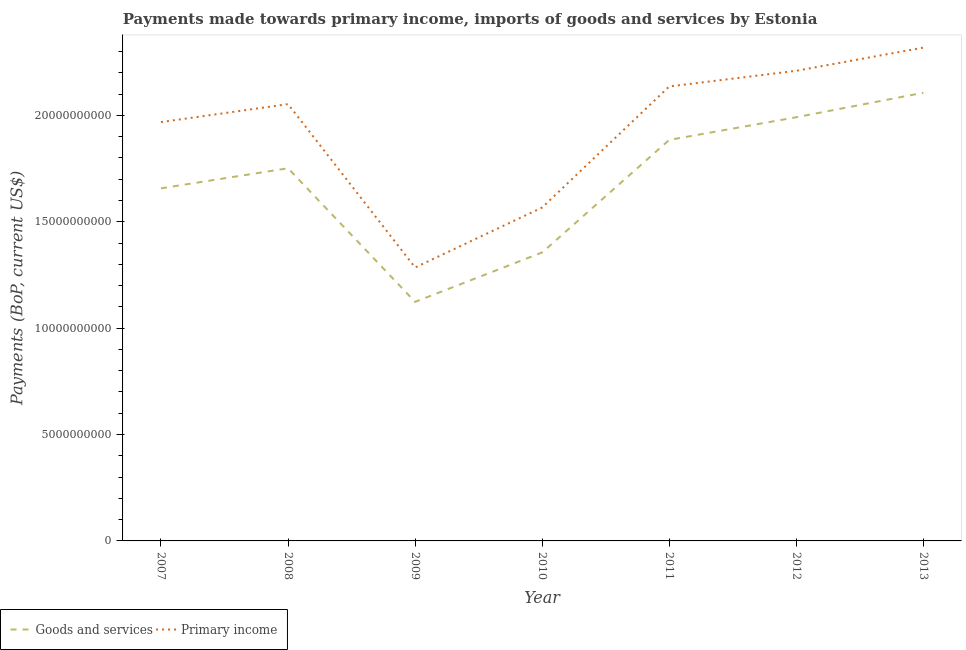How many different coloured lines are there?
Your answer should be very brief. 2. Does the line corresponding to payments made towards primary income intersect with the line corresponding to payments made towards goods and services?
Make the answer very short. No. Is the number of lines equal to the number of legend labels?
Offer a very short reply. Yes. What is the payments made towards goods and services in 2010?
Offer a terse response. 1.36e+1. Across all years, what is the maximum payments made towards primary income?
Provide a succinct answer. 2.32e+1. Across all years, what is the minimum payments made towards goods and services?
Give a very brief answer. 1.12e+1. In which year was the payments made towards primary income minimum?
Your answer should be very brief. 2009. What is the total payments made towards primary income in the graph?
Provide a succinct answer. 1.35e+11. What is the difference between the payments made towards goods and services in 2008 and that in 2010?
Your answer should be very brief. 3.96e+09. What is the difference between the payments made towards primary income in 2013 and the payments made towards goods and services in 2007?
Offer a terse response. 6.61e+09. What is the average payments made towards primary income per year?
Offer a terse response. 1.93e+1. In the year 2011, what is the difference between the payments made towards goods and services and payments made towards primary income?
Keep it short and to the point. -2.51e+09. What is the ratio of the payments made towards primary income in 2007 to that in 2008?
Your answer should be very brief. 0.96. What is the difference between the highest and the second highest payments made towards primary income?
Give a very brief answer. 1.09e+09. What is the difference between the highest and the lowest payments made towards goods and services?
Ensure brevity in your answer.  9.83e+09. Is the sum of the payments made towards primary income in 2007 and 2012 greater than the maximum payments made towards goods and services across all years?
Keep it short and to the point. Yes. Does the payments made towards primary income monotonically increase over the years?
Your answer should be compact. No. Is the payments made towards primary income strictly less than the payments made towards goods and services over the years?
Offer a very short reply. No. How many lines are there?
Your answer should be very brief. 2. Does the graph contain any zero values?
Keep it short and to the point. No. Does the graph contain grids?
Keep it short and to the point. No. Where does the legend appear in the graph?
Your answer should be very brief. Bottom left. How are the legend labels stacked?
Offer a terse response. Horizontal. What is the title of the graph?
Your answer should be very brief. Payments made towards primary income, imports of goods and services by Estonia. What is the label or title of the X-axis?
Keep it short and to the point. Year. What is the label or title of the Y-axis?
Provide a short and direct response. Payments (BoP, current US$). What is the Payments (BoP, current US$) in Goods and services in 2007?
Your response must be concise. 1.66e+1. What is the Payments (BoP, current US$) of Primary income in 2007?
Provide a short and direct response. 1.97e+1. What is the Payments (BoP, current US$) in Goods and services in 2008?
Offer a terse response. 1.75e+1. What is the Payments (BoP, current US$) of Primary income in 2008?
Offer a very short reply. 2.05e+1. What is the Payments (BoP, current US$) of Goods and services in 2009?
Make the answer very short. 1.12e+1. What is the Payments (BoP, current US$) in Primary income in 2009?
Your answer should be compact. 1.29e+1. What is the Payments (BoP, current US$) in Goods and services in 2010?
Provide a succinct answer. 1.36e+1. What is the Payments (BoP, current US$) of Primary income in 2010?
Provide a short and direct response. 1.57e+1. What is the Payments (BoP, current US$) of Goods and services in 2011?
Make the answer very short. 1.88e+1. What is the Payments (BoP, current US$) of Primary income in 2011?
Ensure brevity in your answer.  2.14e+1. What is the Payments (BoP, current US$) in Goods and services in 2012?
Offer a very short reply. 1.99e+1. What is the Payments (BoP, current US$) of Primary income in 2012?
Offer a very short reply. 2.21e+1. What is the Payments (BoP, current US$) of Goods and services in 2013?
Ensure brevity in your answer.  2.11e+1. What is the Payments (BoP, current US$) in Primary income in 2013?
Give a very brief answer. 2.32e+1. Across all years, what is the maximum Payments (BoP, current US$) of Goods and services?
Your response must be concise. 2.11e+1. Across all years, what is the maximum Payments (BoP, current US$) of Primary income?
Keep it short and to the point. 2.32e+1. Across all years, what is the minimum Payments (BoP, current US$) of Goods and services?
Offer a terse response. 1.12e+1. Across all years, what is the minimum Payments (BoP, current US$) of Primary income?
Your answer should be compact. 1.29e+1. What is the total Payments (BoP, current US$) in Goods and services in the graph?
Ensure brevity in your answer.  1.19e+11. What is the total Payments (BoP, current US$) of Primary income in the graph?
Make the answer very short. 1.35e+11. What is the difference between the Payments (BoP, current US$) of Goods and services in 2007 and that in 2008?
Provide a short and direct response. -9.43e+08. What is the difference between the Payments (BoP, current US$) in Primary income in 2007 and that in 2008?
Offer a terse response. -8.45e+08. What is the difference between the Payments (BoP, current US$) of Goods and services in 2007 and that in 2009?
Make the answer very short. 5.34e+09. What is the difference between the Payments (BoP, current US$) of Primary income in 2007 and that in 2009?
Give a very brief answer. 6.83e+09. What is the difference between the Payments (BoP, current US$) of Goods and services in 2007 and that in 2010?
Give a very brief answer. 3.01e+09. What is the difference between the Payments (BoP, current US$) in Primary income in 2007 and that in 2010?
Provide a succinct answer. 4.01e+09. What is the difference between the Payments (BoP, current US$) in Goods and services in 2007 and that in 2011?
Give a very brief answer. -2.28e+09. What is the difference between the Payments (BoP, current US$) of Primary income in 2007 and that in 2011?
Provide a short and direct response. -1.67e+09. What is the difference between the Payments (BoP, current US$) in Goods and services in 2007 and that in 2012?
Provide a succinct answer. -3.34e+09. What is the difference between the Payments (BoP, current US$) in Primary income in 2007 and that in 2012?
Your response must be concise. -2.41e+09. What is the difference between the Payments (BoP, current US$) of Goods and services in 2007 and that in 2013?
Provide a succinct answer. -4.49e+09. What is the difference between the Payments (BoP, current US$) in Primary income in 2007 and that in 2013?
Give a very brief answer. -3.50e+09. What is the difference between the Payments (BoP, current US$) of Goods and services in 2008 and that in 2009?
Make the answer very short. 6.28e+09. What is the difference between the Payments (BoP, current US$) of Primary income in 2008 and that in 2009?
Make the answer very short. 7.68e+09. What is the difference between the Payments (BoP, current US$) in Goods and services in 2008 and that in 2010?
Your answer should be compact. 3.96e+09. What is the difference between the Payments (BoP, current US$) of Primary income in 2008 and that in 2010?
Provide a short and direct response. 4.86e+09. What is the difference between the Payments (BoP, current US$) in Goods and services in 2008 and that in 2011?
Your answer should be compact. -1.33e+09. What is the difference between the Payments (BoP, current US$) of Primary income in 2008 and that in 2011?
Offer a very short reply. -8.30e+08. What is the difference between the Payments (BoP, current US$) in Goods and services in 2008 and that in 2012?
Your response must be concise. -2.40e+09. What is the difference between the Payments (BoP, current US$) in Primary income in 2008 and that in 2012?
Make the answer very short. -1.57e+09. What is the difference between the Payments (BoP, current US$) in Goods and services in 2008 and that in 2013?
Your answer should be very brief. -3.55e+09. What is the difference between the Payments (BoP, current US$) of Primary income in 2008 and that in 2013?
Offer a very short reply. -2.66e+09. What is the difference between the Payments (BoP, current US$) in Goods and services in 2009 and that in 2010?
Offer a terse response. -2.32e+09. What is the difference between the Payments (BoP, current US$) in Primary income in 2009 and that in 2010?
Your answer should be very brief. -2.82e+09. What is the difference between the Payments (BoP, current US$) in Goods and services in 2009 and that in 2011?
Ensure brevity in your answer.  -7.61e+09. What is the difference between the Payments (BoP, current US$) in Primary income in 2009 and that in 2011?
Your response must be concise. -8.51e+09. What is the difference between the Payments (BoP, current US$) in Goods and services in 2009 and that in 2012?
Give a very brief answer. -8.68e+09. What is the difference between the Payments (BoP, current US$) in Primary income in 2009 and that in 2012?
Your answer should be very brief. -9.24e+09. What is the difference between the Payments (BoP, current US$) of Goods and services in 2009 and that in 2013?
Ensure brevity in your answer.  -9.83e+09. What is the difference between the Payments (BoP, current US$) in Primary income in 2009 and that in 2013?
Your answer should be compact. -1.03e+1. What is the difference between the Payments (BoP, current US$) of Goods and services in 2010 and that in 2011?
Offer a terse response. -5.29e+09. What is the difference between the Payments (BoP, current US$) in Primary income in 2010 and that in 2011?
Ensure brevity in your answer.  -5.69e+09. What is the difference between the Payments (BoP, current US$) of Goods and services in 2010 and that in 2012?
Offer a very short reply. -6.36e+09. What is the difference between the Payments (BoP, current US$) of Primary income in 2010 and that in 2012?
Provide a succinct answer. -6.42e+09. What is the difference between the Payments (BoP, current US$) of Goods and services in 2010 and that in 2013?
Keep it short and to the point. -7.51e+09. What is the difference between the Payments (BoP, current US$) of Primary income in 2010 and that in 2013?
Your answer should be very brief. -7.51e+09. What is the difference between the Payments (BoP, current US$) in Goods and services in 2011 and that in 2012?
Ensure brevity in your answer.  -1.07e+09. What is the difference between the Payments (BoP, current US$) of Primary income in 2011 and that in 2012?
Offer a terse response. -7.37e+08. What is the difference between the Payments (BoP, current US$) of Goods and services in 2011 and that in 2013?
Your answer should be compact. -2.22e+09. What is the difference between the Payments (BoP, current US$) in Primary income in 2011 and that in 2013?
Make the answer very short. -1.83e+09. What is the difference between the Payments (BoP, current US$) in Goods and services in 2012 and that in 2013?
Give a very brief answer. -1.15e+09. What is the difference between the Payments (BoP, current US$) in Primary income in 2012 and that in 2013?
Provide a succinct answer. -1.09e+09. What is the difference between the Payments (BoP, current US$) in Goods and services in 2007 and the Payments (BoP, current US$) in Primary income in 2008?
Your response must be concise. -3.96e+09. What is the difference between the Payments (BoP, current US$) of Goods and services in 2007 and the Payments (BoP, current US$) of Primary income in 2009?
Provide a succinct answer. 3.72e+09. What is the difference between the Payments (BoP, current US$) in Goods and services in 2007 and the Payments (BoP, current US$) in Primary income in 2010?
Keep it short and to the point. 9.01e+08. What is the difference between the Payments (BoP, current US$) in Goods and services in 2007 and the Payments (BoP, current US$) in Primary income in 2011?
Your answer should be compact. -4.79e+09. What is the difference between the Payments (BoP, current US$) in Goods and services in 2007 and the Payments (BoP, current US$) in Primary income in 2012?
Your answer should be compact. -5.52e+09. What is the difference between the Payments (BoP, current US$) of Goods and services in 2007 and the Payments (BoP, current US$) of Primary income in 2013?
Keep it short and to the point. -6.61e+09. What is the difference between the Payments (BoP, current US$) of Goods and services in 2008 and the Payments (BoP, current US$) of Primary income in 2009?
Provide a succinct answer. 4.66e+09. What is the difference between the Payments (BoP, current US$) of Goods and services in 2008 and the Payments (BoP, current US$) of Primary income in 2010?
Your response must be concise. 1.84e+09. What is the difference between the Payments (BoP, current US$) of Goods and services in 2008 and the Payments (BoP, current US$) of Primary income in 2011?
Provide a short and direct response. -3.84e+09. What is the difference between the Payments (BoP, current US$) in Goods and services in 2008 and the Payments (BoP, current US$) in Primary income in 2012?
Make the answer very short. -4.58e+09. What is the difference between the Payments (BoP, current US$) of Goods and services in 2008 and the Payments (BoP, current US$) of Primary income in 2013?
Provide a succinct answer. -5.67e+09. What is the difference between the Payments (BoP, current US$) in Goods and services in 2009 and the Payments (BoP, current US$) in Primary income in 2010?
Offer a very short reply. -4.44e+09. What is the difference between the Payments (BoP, current US$) in Goods and services in 2009 and the Payments (BoP, current US$) in Primary income in 2011?
Make the answer very short. -1.01e+1. What is the difference between the Payments (BoP, current US$) in Goods and services in 2009 and the Payments (BoP, current US$) in Primary income in 2012?
Your answer should be compact. -1.09e+1. What is the difference between the Payments (BoP, current US$) of Goods and services in 2009 and the Payments (BoP, current US$) of Primary income in 2013?
Make the answer very short. -1.20e+1. What is the difference between the Payments (BoP, current US$) in Goods and services in 2010 and the Payments (BoP, current US$) in Primary income in 2011?
Make the answer very short. -7.80e+09. What is the difference between the Payments (BoP, current US$) in Goods and services in 2010 and the Payments (BoP, current US$) in Primary income in 2012?
Give a very brief answer. -8.54e+09. What is the difference between the Payments (BoP, current US$) of Goods and services in 2010 and the Payments (BoP, current US$) of Primary income in 2013?
Offer a terse response. -9.63e+09. What is the difference between the Payments (BoP, current US$) in Goods and services in 2011 and the Payments (BoP, current US$) in Primary income in 2012?
Provide a short and direct response. -3.25e+09. What is the difference between the Payments (BoP, current US$) in Goods and services in 2011 and the Payments (BoP, current US$) in Primary income in 2013?
Make the answer very short. -4.34e+09. What is the difference between the Payments (BoP, current US$) of Goods and services in 2012 and the Payments (BoP, current US$) of Primary income in 2013?
Your answer should be compact. -3.27e+09. What is the average Payments (BoP, current US$) in Goods and services per year?
Ensure brevity in your answer.  1.70e+1. What is the average Payments (BoP, current US$) in Primary income per year?
Provide a succinct answer. 1.93e+1. In the year 2007, what is the difference between the Payments (BoP, current US$) in Goods and services and Payments (BoP, current US$) in Primary income?
Keep it short and to the point. -3.11e+09. In the year 2008, what is the difference between the Payments (BoP, current US$) of Goods and services and Payments (BoP, current US$) of Primary income?
Make the answer very short. -3.01e+09. In the year 2009, what is the difference between the Payments (BoP, current US$) of Goods and services and Payments (BoP, current US$) of Primary income?
Provide a short and direct response. -1.62e+09. In the year 2010, what is the difference between the Payments (BoP, current US$) in Goods and services and Payments (BoP, current US$) in Primary income?
Offer a very short reply. -2.11e+09. In the year 2011, what is the difference between the Payments (BoP, current US$) of Goods and services and Payments (BoP, current US$) of Primary income?
Provide a succinct answer. -2.51e+09. In the year 2012, what is the difference between the Payments (BoP, current US$) of Goods and services and Payments (BoP, current US$) of Primary income?
Give a very brief answer. -2.18e+09. In the year 2013, what is the difference between the Payments (BoP, current US$) in Goods and services and Payments (BoP, current US$) in Primary income?
Give a very brief answer. -2.12e+09. What is the ratio of the Payments (BoP, current US$) in Goods and services in 2007 to that in 2008?
Your answer should be compact. 0.95. What is the ratio of the Payments (BoP, current US$) of Primary income in 2007 to that in 2008?
Your answer should be compact. 0.96. What is the ratio of the Payments (BoP, current US$) in Goods and services in 2007 to that in 2009?
Offer a terse response. 1.47. What is the ratio of the Payments (BoP, current US$) of Primary income in 2007 to that in 2009?
Your answer should be very brief. 1.53. What is the ratio of the Payments (BoP, current US$) of Goods and services in 2007 to that in 2010?
Your answer should be very brief. 1.22. What is the ratio of the Payments (BoP, current US$) in Primary income in 2007 to that in 2010?
Ensure brevity in your answer.  1.26. What is the ratio of the Payments (BoP, current US$) in Goods and services in 2007 to that in 2011?
Your response must be concise. 0.88. What is the ratio of the Payments (BoP, current US$) in Primary income in 2007 to that in 2011?
Make the answer very short. 0.92. What is the ratio of the Payments (BoP, current US$) of Goods and services in 2007 to that in 2012?
Your answer should be compact. 0.83. What is the ratio of the Payments (BoP, current US$) of Primary income in 2007 to that in 2012?
Offer a very short reply. 0.89. What is the ratio of the Payments (BoP, current US$) in Goods and services in 2007 to that in 2013?
Your answer should be compact. 0.79. What is the ratio of the Payments (BoP, current US$) of Primary income in 2007 to that in 2013?
Provide a succinct answer. 0.85. What is the ratio of the Payments (BoP, current US$) of Goods and services in 2008 to that in 2009?
Offer a very short reply. 1.56. What is the ratio of the Payments (BoP, current US$) in Primary income in 2008 to that in 2009?
Offer a terse response. 1.6. What is the ratio of the Payments (BoP, current US$) of Goods and services in 2008 to that in 2010?
Provide a succinct answer. 1.29. What is the ratio of the Payments (BoP, current US$) of Primary income in 2008 to that in 2010?
Your answer should be very brief. 1.31. What is the ratio of the Payments (BoP, current US$) of Goods and services in 2008 to that in 2011?
Your response must be concise. 0.93. What is the ratio of the Payments (BoP, current US$) in Primary income in 2008 to that in 2011?
Offer a very short reply. 0.96. What is the ratio of the Payments (BoP, current US$) in Goods and services in 2008 to that in 2012?
Keep it short and to the point. 0.88. What is the ratio of the Payments (BoP, current US$) of Primary income in 2008 to that in 2012?
Provide a short and direct response. 0.93. What is the ratio of the Payments (BoP, current US$) in Goods and services in 2008 to that in 2013?
Keep it short and to the point. 0.83. What is the ratio of the Payments (BoP, current US$) of Primary income in 2008 to that in 2013?
Your response must be concise. 0.89. What is the ratio of the Payments (BoP, current US$) in Goods and services in 2009 to that in 2010?
Provide a short and direct response. 0.83. What is the ratio of the Payments (BoP, current US$) in Primary income in 2009 to that in 2010?
Your response must be concise. 0.82. What is the ratio of the Payments (BoP, current US$) in Goods and services in 2009 to that in 2011?
Keep it short and to the point. 0.6. What is the ratio of the Payments (BoP, current US$) in Primary income in 2009 to that in 2011?
Your response must be concise. 0.6. What is the ratio of the Payments (BoP, current US$) of Goods and services in 2009 to that in 2012?
Make the answer very short. 0.56. What is the ratio of the Payments (BoP, current US$) of Primary income in 2009 to that in 2012?
Make the answer very short. 0.58. What is the ratio of the Payments (BoP, current US$) in Goods and services in 2009 to that in 2013?
Offer a terse response. 0.53. What is the ratio of the Payments (BoP, current US$) in Primary income in 2009 to that in 2013?
Provide a short and direct response. 0.55. What is the ratio of the Payments (BoP, current US$) of Goods and services in 2010 to that in 2011?
Your response must be concise. 0.72. What is the ratio of the Payments (BoP, current US$) of Primary income in 2010 to that in 2011?
Offer a very short reply. 0.73. What is the ratio of the Payments (BoP, current US$) of Goods and services in 2010 to that in 2012?
Give a very brief answer. 0.68. What is the ratio of the Payments (BoP, current US$) in Primary income in 2010 to that in 2012?
Offer a terse response. 0.71. What is the ratio of the Payments (BoP, current US$) of Goods and services in 2010 to that in 2013?
Provide a short and direct response. 0.64. What is the ratio of the Payments (BoP, current US$) of Primary income in 2010 to that in 2013?
Offer a terse response. 0.68. What is the ratio of the Payments (BoP, current US$) of Goods and services in 2011 to that in 2012?
Keep it short and to the point. 0.95. What is the ratio of the Payments (BoP, current US$) in Primary income in 2011 to that in 2012?
Offer a very short reply. 0.97. What is the ratio of the Payments (BoP, current US$) in Goods and services in 2011 to that in 2013?
Your answer should be compact. 0.89. What is the ratio of the Payments (BoP, current US$) of Primary income in 2011 to that in 2013?
Offer a terse response. 0.92. What is the ratio of the Payments (BoP, current US$) in Goods and services in 2012 to that in 2013?
Provide a short and direct response. 0.95. What is the ratio of the Payments (BoP, current US$) of Primary income in 2012 to that in 2013?
Keep it short and to the point. 0.95. What is the difference between the highest and the second highest Payments (BoP, current US$) in Goods and services?
Offer a terse response. 1.15e+09. What is the difference between the highest and the second highest Payments (BoP, current US$) in Primary income?
Make the answer very short. 1.09e+09. What is the difference between the highest and the lowest Payments (BoP, current US$) of Goods and services?
Offer a terse response. 9.83e+09. What is the difference between the highest and the lowest Payments (BoP, current US$) in Primary income?
Give a very brief answer. 1.03e+1. 